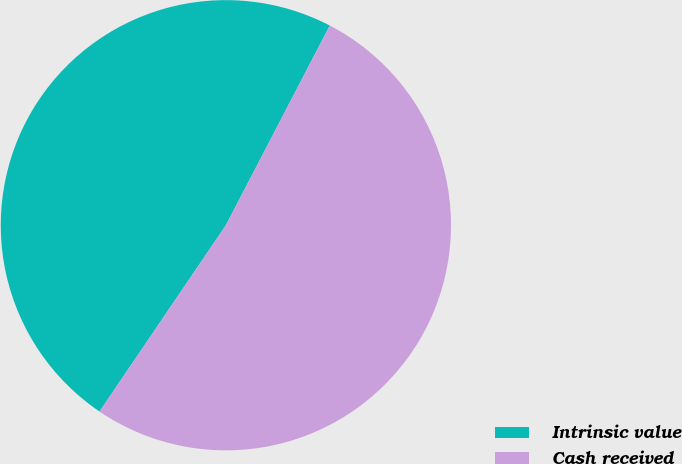<chart> <loc_0><loc_0><loc_500><loc_500><pie_chart><fcel>Intrinsic value<fcel>Cash received<nl><fcel>48.15%<fcel>51.85%<nl></chart> 